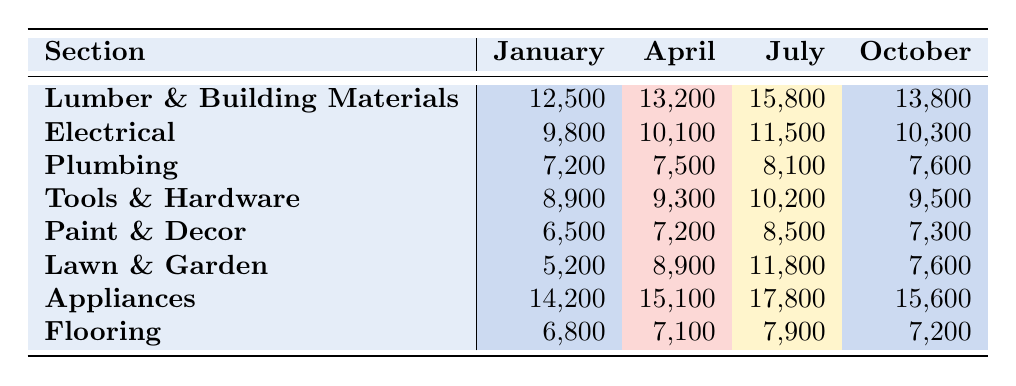What is the energy consumption of the Appliances section in July? The table shows that the energy consumption for the Appliances section in July is 17,800.
Answer: 17,800 Which section had the highest energy consumption in October? By examining the table, the Appliances section had the highest energy consumption in October at 15,600.
Answer: Appliances How much more energy was consumed in the Lumber & Building Materials section in July compared to January? The consumption in July was 15,800 and in January it was 12,500; the difference is 15,800 - 12,500 = 3,300.
Answer: 3,300 What is the total energy consumption of the Lawn & Garden section from January to October? Adding the values: 5,200 (January) + 8,900 (April) + 11,800 (July) + 7,600 (October) equals 33,500.
Answer: 33,500 Is the energy consumption in February available for any section? The table does not provide any values for February, so the answer is no.
Answer: No What is the average energy consumption of the Tools & Hardware section across the recorded months? Adding the values: 8,900 (January) + 9,300 (April) + 10,200 (July) + 9,500 (October) = 37,900; then dividing by 4 gives an average of 37,900 / 4 = 9,475.
Answer: 9,475 Which month had the lowest average consumption across all sections listed? To find this, we can consider the provided values: January totals 78,500; April totals 80,000; July totals 97,900; October totals 80,600. January has the lowest total energy consumption at 78,500, making it the lowest month.
Answer: January If we combine the energy consumption of the Electrical and Plumbing sections in July, what do we get? The Electrical section consumed 11,500 and Plumbing consumed 8,100 in July; their total is 11,500 + 8,100 = 19,600.
Answer: 19,600 Did any section see an increase in energy consumption from April to July? Comparing April and July values, every section shows an increase in consumption from April to July. Therefore, the answer is yes.
Answer: Yes What is the difference in energy consumption between the highest and lowest sections in April? The highest is Appliances at 15,100 and the lowest is Plumbing at 7,500; the difference is 15,100 - 7,500 = 7,600.
Answer: 7,600 